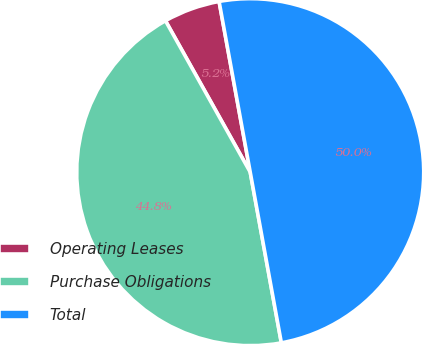Convert chart to OTSL. <chart><loc_0><loc_0><loc_500><loc_500><pie_chart><fcel>Operating Leases<fcel>Purchase Obligations<fcel>Total<nl><fcel>5.25%<fcel>44.75%<fcel>50.0%<nl></chart> 